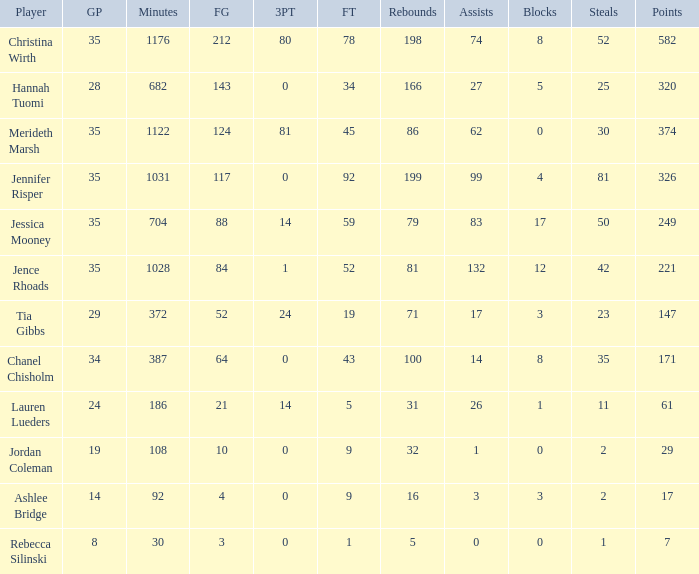How much time, in minutes, did Chanel Chisholm play? 1.0. 